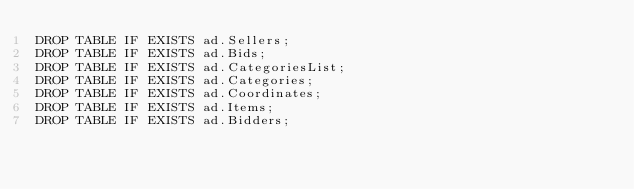Convert code to text. <code><loc_0><loc_0><loc_500><loc_500><_SQL_>DROP TABLE IF EXISTS ad.Sellers;
DROP TABLE IF EXISTS ad.Bids;
DROP TABLE IF EXISTS ad.CategoriesList;
DROP TABLE IF EXISTS ad.Categories;
DROP TABLE IF EXISTS ad.Coordinates;
DROP TABLE IF EXISTS ad.Items;
DROP TABLE IF EXISTS ad.Bidders;</code> 